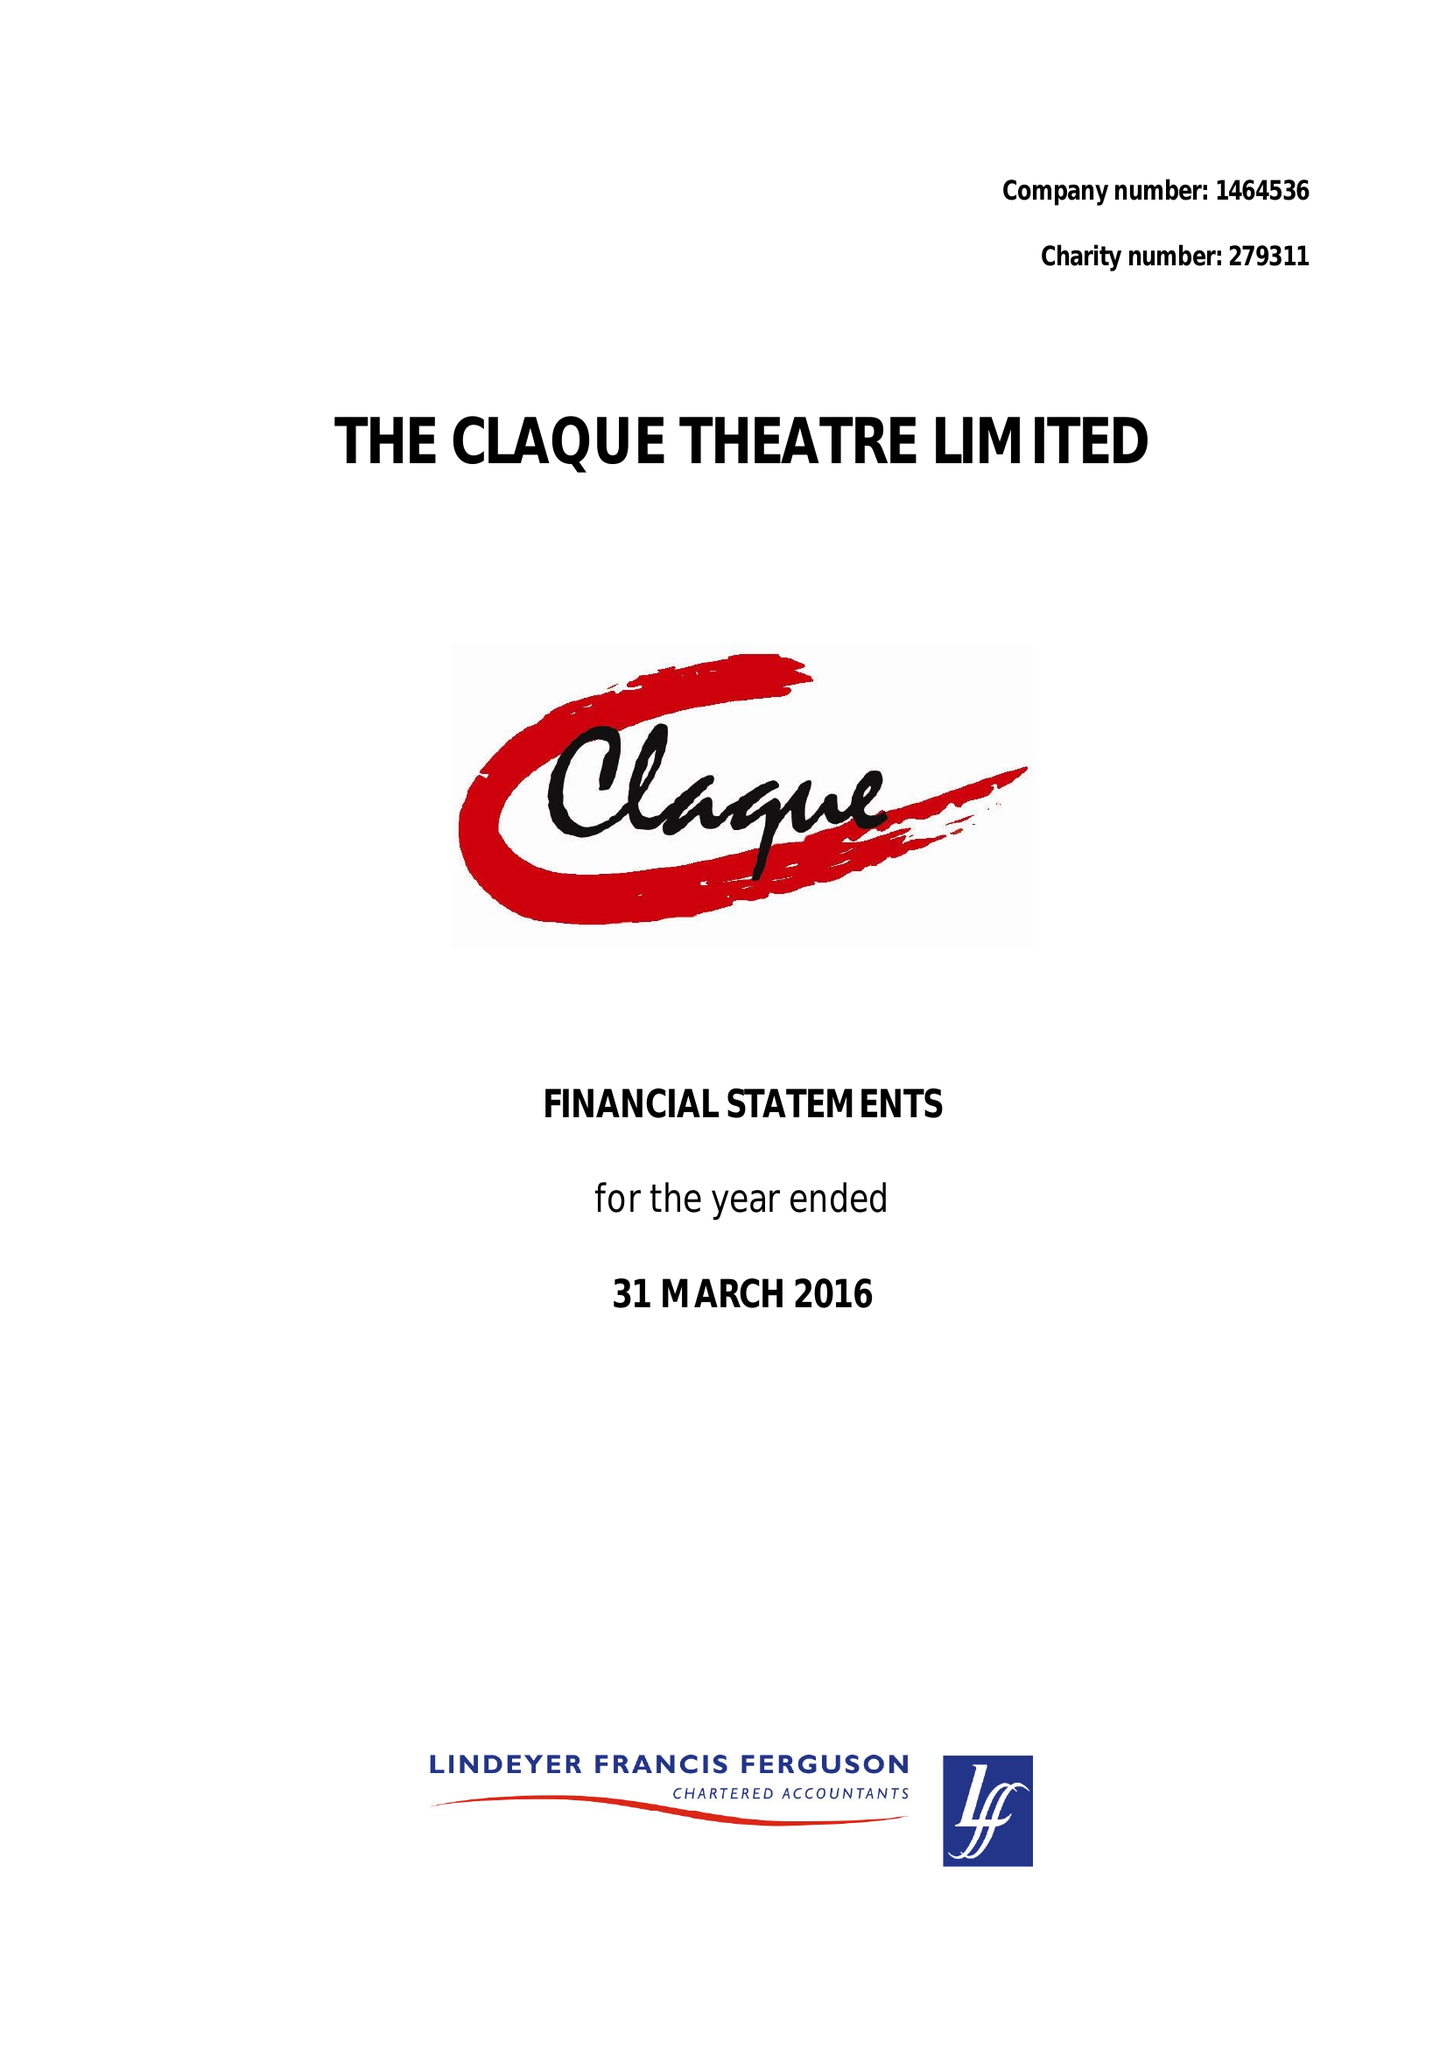What is the value for the charity_name?
Answer the question using a single word or phrase. The Claque Theatre Ltd. 